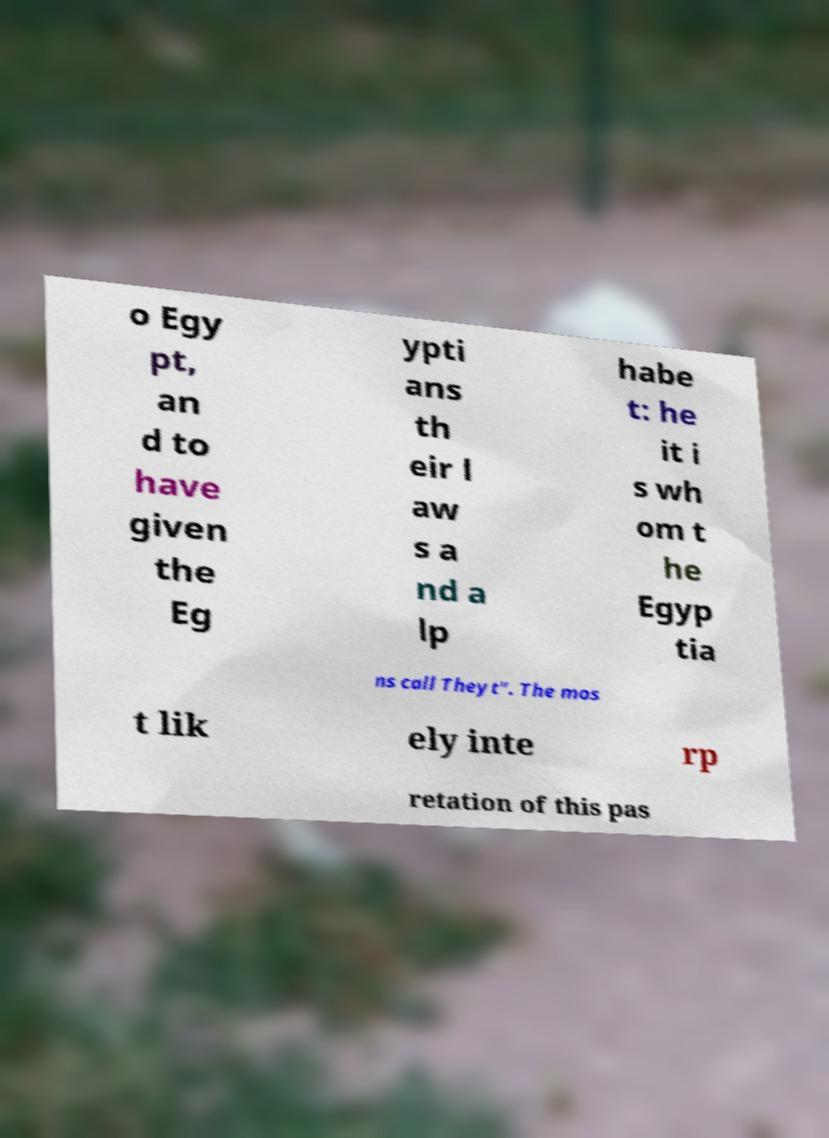There's text embedded in this image that I need extracted. Can you transcribe it verbatim? o Egy pt, an d to have given the Eg ypti ans th eir l aw s a nd a lp habe t: he it i s wh om t he Egyp tia ns call Theyt". The mos t lik ely inte rp retation of this pas 